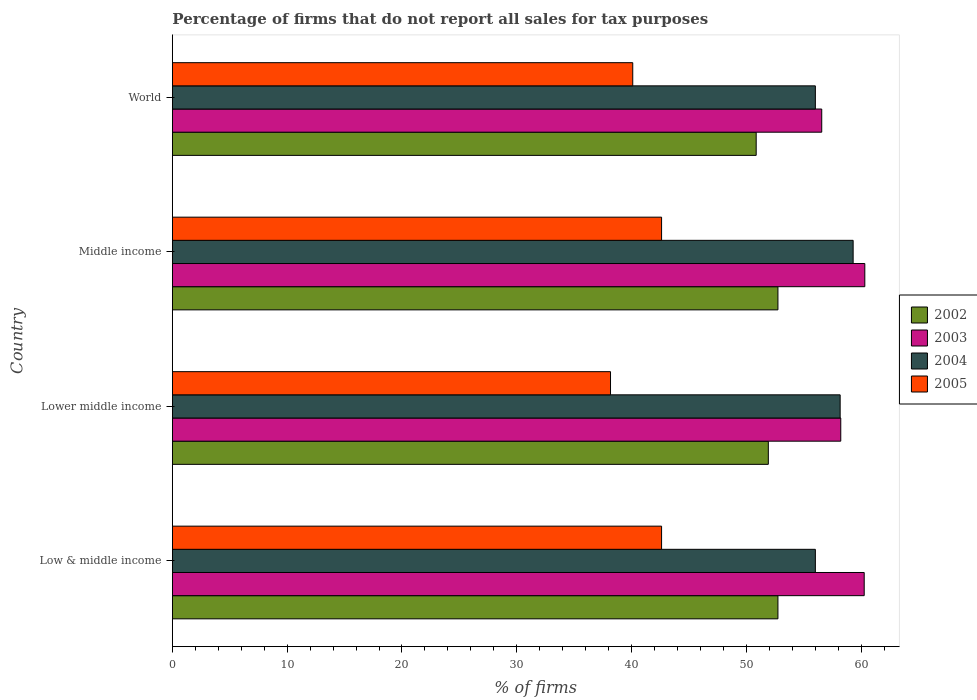How many different coloured bars are there?
Keep it short and to the point. 4. How many groups of bars are there?
Make the answer very short. 4. Are the number of bars on each tick of the Y-axis equal?
Provide a succinct answer. Yes. How many bars are there on the 1st tick from the bottom?
Ensure brevity in your answer.  4. What is the label of the 4th group of bars from the top?
Keep it short and to the point. Low & middle income. In how many cases, is the number of bars for a given country not equal to the number of legend labels?
Keep it short and to the point. 0. What is the percentage of firms that do not report all sales for tax purposes in 2004 in Lower middle income?
Your answer should be very brief. 58.16. Across all countries, what is the maximum percentage of firms that do not report all sales for tax purposes in 2003?
Give a very brief answer. 60.31. Across all countries, what is the minimum percentage of firms that do not report all sales for tax purposes in 2005?
Provide a succinct answer. 38.16. In which country was the percentage of firms that do not report all sales for tax purposes in 2002 maximum?
Make the answer very short. Low & middle income. In which country was the percentage of firms that do not report all sales for tax purposes in 2002 minimum?
Give a very brief answer. World. What is the total percentage of firms that do not report all sales for tax purposes in 2004 in the graph?
Provide a succinct answer. 229.47. What is the difference between the percentage of firms that do not report all sales for tax purposes in 2005 in Low & middle income and that in World?
Give a very brief answer. 2.51. What is the difference between the percentage of firms that do not report all sales for tax purposes in 2003 in Middle income and the percentage of firms that do not report all sales for tax purposes in 2005 in World?
Provide a short and direct response. 20.21. What is the average percentage of firms that do not report all sales for tax purposes in 2002 per country?
Your answer should be compact. 52.06. What is the difference between the percentage of firms that do not report all sales for tax purposes in 2004 and percentage of firms that do not report all sales for tax purposes in 2005 in World?
Your answer should be compact. 15.91. In how many countries, is the percentage of firms that do not report all sales for tax purposes in 2003 greater than 26 %?
Provide a short and direct response. 4. What is the ratio of the percentage of firms that do not report all sales for tax purposes in 2004 in Low & middle income to that in Lower middle income?
Offer a very short reply. 0.96. What is the difference between the highest and the second highest percentage of firms that do not report all sales for tax purposes in 2004?
Your answer should be compact. 1.13. What is the difference between the highest and the lowest percentage of firms that do not report all sales for tax purposes in 2003?
Offer a very short reply. 3.75. Is it the case that in every country, the sum of the percentage of firms that do not report all sales for tax purposes in 2004 and percentage of firms that do not report all sales for tax purposes in 2005 is greater than the sum of percentage of firms that do not report all sales for tax purposes in 2002 and percentage of firms that do not report all sales for tax purposes in 2003?
Ensure brevity in your answer.  Yes. What does the 2nd bar from the top in Low & middle income represents?
Your answer should be very brief. 2004. Is it the case that in every country, the sum of the percentage of firms that do not report all sales for tax purposes in 2003 and percentage of firms that do not report all sales for tax purposes in 2002 is greater than the percentage of firms that do not report all sales for tax purposes in 2005?
Your answer should be compact. Yes. Are all the bars in the graph horizontal?
Offer a terse response. Yes. Are the values on the major ticks of X-axis written in scientific E-notation?
Provide a short and direct response. No. Does the graph contain grids?
Your answer should be very brief. No. How many legend labels are there?
Keep it short and to the point. 4. How are the legend labels stacked?
Make the answer very short. Vertical. What is the title of the graph?
Provide a short and direct response. Percentage of firms that do not report all sales for tax purposes. What is the label or title of the X-axis?
Offer a very short reply. % of firms. What is the % of firms in 2002 in Low & middle income?
Your response must be concise. 52.75. What is the % of firms of 2003 in Low & middle income?
Your response must be concise. 60.26. What is the % of firms in 2004 in Low & middle income?
Make the answer very short. 56.01. What is the % of firms of 2005 in Low & middle income?
Offer a terse response. 42.61. What is the % of firms of 2002 in Lower middle income?
Your answer should be compact. 51.91. What is the % of firms of 2003 in Lower middle income?
Keep it short and to the point. 58.22. What is the % of firms in 2004 in Lower middle income?
Offer a terse response. 58.16. What is the % of firms of 2005 in Lower middle income?
Offer a very short reply. 38.16. What is the % of firms in 2002 in Middle income?
Your response must be concise. 52.75. What is the % of firms of 2003 in Middle income?
Your response must be concise. 60.31. What is the % of firms of 2004 in Middle income?
Offer a terse response. 59.3. What is the % of firms of 2005 in Middle income?
Provide a succinct answer. 42.61. What is the % of firms in 2002 in World?
Give a very brief answer. 50.85. What is the % of firms of 2003 in World?
Your answer should be very brief. 56.56. What is the % of firms of 2004 in World?
Give a very brief answer. 56.01. What is the % of firms in 2005 in World?
Provide a succinct answer. 40.1. Across all countries, what is the maximum % of firms in 2002?
Keep it short and to the point. 52.75. Across all countries, what is the maximum % of firms in 2003?
Keep it short and to the point. 60.31. Across all countries, what is the maximum % of firms of 2004?
Offer a very short reply. 59.3. Across all countries, what is the maximum % of firms of 2005?
Provide a succinct answer. 42.61. Across all countries, what is the minimum % of firms in 2002?
Give a very brief answer. 50.85. Across all countries, what is the minimum % of firms of 2003?
Your answer should be compact. 56.56. Across all countries, what is the minimum % of firms of 2004?
Keep it short and to the point. 56.01. Across all countries, what is the minimum % of firms of 2005?
Make the answer very short. 38.16. What is the total % of firms in 2002 in the graph?
Make the answer very short. 208.25. What is the total % of firms in 2003 in the graph?
Keep it short and to the point. 235.35. What is the total % of firms of 2004 in the graph?
Provide a succinct answer. 229.47. What is the total % of firms of 2005 in the graph?
Offer a terse response. 163.48. What is the difference between the % of firms in 2002 in Low & middle income and that in Lower middle income?
Offer a terse response. 0.84. What is the difference between the % of firms in 2003 in Low & middle income and that in Lower middle income?
Offer a terse response. 2.04. What is the difference between the % of firms in 2004 in Low & middle income and that in Lower middle income?
Keep it short and to the point. -2.16. What is the difference between the % of firms in 2005 in Low & middle income and that in Lower middle income?
Ensure brevity in your answer.  4.45. What is the difference between the % of firms in 2002 in Low & middle income and that in Middle income?
Provide a short and direct response. 0. What is the difference between the % of firms of 2003 in Low & middle income and that in Middle income?
Keep it short and to the point. -0.05. What is the difference between the % of firms in 2004 in Low & middle income and that in Middle income?
Your answer should be compact. -3.29. What is the difference between the % of firms of 2002 in Low & middle income and that in World?
Keep it short and to the point. 1.89. What is the difference between the % of firms in 2004 in Low & middle income and that in World?
Give a very brief answer. 0. What is the difference between the % of firms in 2005 in Low & middle income and that in World?
Give a very brief answer. 2.51. What is the difference between the % of firms of 2002 in Lower middle income and that in Middle income?
Provide a succinct answer. -0.84. What is the difference between the % of firms in 2003 in Lower middle income and that in Middle income?
Make the answer very short. -2.09. What is the difference between the % of firms of 2004 in Lower middle income and that in Middle income?
Ensure brevity in your answer.  -1.13. What is the difference between the % of firms of 2005 in Lower middle income and that in Middle income?
Make the answer very short. -4.45. What is the difference between the % of firms in 2002 in Lower middle income and that in World?
Provide a succinct answer. 1.06. What is the difference between the % of firms of 2003 in Lower middle income and that in World?
Give a very brief answer. 1.66. What is the difference between the % of firms in 2004 in Lower middle income and that in World?
Offer a very short reply. 2.16. What is the difference between the % of firms of 2005 in Lower middle income and that in World?
Make the answer very short. -1.94. What is the difference between the % of firms of 2002 in Middle income and that in World?
Ensure brevity in your answer.  1.89. What is the difference between the % of firms of 2003 in Middle income and that in World?
Keep it short and to the point. 3.75. What is the difference between the % of firms of 2004 in Middle income and that in World?
Your response must be concise. 3.29. What is the difference between the % of firms of 2005 in Middle income and that in World?
Give a very brief answer. 2.51. What is the difference between the % of firms in 2002 in Low & middle income and the % of firms in 2003 in Lower middle income?
Your response must be concise. -5.47. What is the difference between the % of firms of 2002 in Low & middle income and the % of firms of 2004 in Lower middle income?
Keep it short and to the point. -5.42. What is the difference between the % of firms of 2002 in Low & middle income and the % of firms of 2005 in Lower middle income?
Provide a succinct answer. 14.58. What is the difference between the % of firms in 2003 in Low & middle income and the % of firms in 2004 in Lower middle income?
Offer a terse response. 2.1. What is the difference between the % of firms of 2003 in Low & middle income and the % of firms of 2005 in Lower middle income?
Give a very brief answer. 22.1. What is the difference between the % of firms of 2004 in Low & middle income and the % of firms of 2005 in Lower middle income?
Offer a terse response. 17.84. What is the difference between the % of firms of 2002 in Low & middle income and the % of firms of 2003 in Middle income?
Offer a terse response. -7.57. What is the difference between the % of firms of 2002 in Low & middle income and the % of firms of 2004 in Middle income?
Ensure brevity in your answer.  -6.55. What is the difference between the % of firms of 2002 in Low & middle income and the % of firms of 2005 in Middle income?
Your response must be concise. 10.13. What is the difference between the % of firms in 2003 in Low & middle income and the % of firms in 2005 in Middle income?
Give a very brief answer. 17.65. What is the difference between the % of firms in 2004 in Low & middle income and the % of firms in 2005 in Middle income?
Provide a succinct answer. 13.39. What is the difference between the % of firms in 2002 in Low & middle income and the % of firms in 2003 in World?
Your answer should be compact. -3.81. What is the difference between the % of firms of 2002 in Low & middle income and the % of firms of 2004 in World?
Give a very brief answer. -3.26. What is the difference between the % of firms in 2002 in Low & middle income and the % of firms in 2005 in World?
Your answer should be very brief. 12.65. What is the difference between the % of firms in 2003 in Low & middle income and the % of firms in 2004 in World?
Keep it short and to the point. 4.25. What is the difference between the % of firms in 2003 in Low & middle income and the % of firms in 2005 in World?
Keep it short and to the point. 20.16. What is the difference between the % of firms of 2004 in Low & middle income and the % of firms of 2005 in World?
Your answer should be compact. 15.91. What is the difference between the % of firms in 2002 in Lower middle income and the % of firms in 2003 in Middle income?
Keep it short and to the point. -8.4. What is the difference between the % of firms of 2002 in Lower middle income and the % of firms of 2004 in Middle income?
Ensure brevity in your answer.  -7.39. What is the difference between the % of firms of 2002 in Lower middle income and the % of firms of 2005 in Middle income?
Make the answer very short. 9.3. What is the difference between the % of firms in 2003 in Lower middle income and the % of firms in 2004 in Middle income?
Provide a short and direct response. -1.08. What is the difference between the % of firms of 2003 in Lower middle income and the % of firms of 2005 in Middle income?
Provide a succinct answer. 15.61. What is the difference between the % of firms of 2004 in Lower middle income and the % of firms of 2005 in Middle income?
Your answer should be compact. 15.55. What is the difference between the % of firms of 2002 in Lower middle income and the % of firms of 2003 in World?
Keep it short and to the point. -4.65. What is the difference between the % of firms in 2002 in Lower middle income and the % of firms in 2004 in World?
Give a very brief answer. -4.1. What is the difference between the % of firms of 2002 in Lower middle income and the % of firms of 2005 in World?
Keep it short and to the point. 11.81. What is the difference between the % of firms in 2003 in Lower middle income and the % of firms in 2004 in World?
Make the answer very short. 2.21. What is the difference between the % of firms of 2003 in Lower middle income and the % of firms of 2005 in World?
Offer a very short reply. 18.12. What is the difference between the % of firms in 2004 in Lower middle income and the % of firms in 2005 in World?
Keep it short and to the point. 18.07. What is the difference between the % of firms of 2002 in Middle income and the % of firms of 2003 in World?
Your response must be concise. -3.81. What is the difference between the % of firms in 2002 in Middle income and the % of firms in 2004 in World?
Provide a short and direct response. -3.26. What is the difference between the % of firms of 2002 in Middle income and the % of firms of 2005 in World?
Give a very brief answer. 12.65. What is the difference between the % of firms of 2003 in Middle income and the % of firms of 2004 in World?
Provide a succinct answer. 4.31. What is the difference between the % of firms of 2003 in Middle income and the % of firms of 2005 in World?
Give a very brief answer. 20.21. What is the difference between the % of firms in 2004 in Middle income and the % of firms in 2005 in World?
Your answer should be compact. 19.2. What is the average % of firms of 2002 per country?
Give a very brief answer. 52.06. What is the average % of firms of 2003 per country?
Give a very brief answer. 58.84. What is the average % of firms in 2004 per country?
Provide a short and direct response. 57.37. What is the average % of firms in 2005 per country?
Keep it short and to the point. 40.87. What is the difference between the % of firms of 2002 and % of firms of 2003 in Low & middle income?
Make the answer very short. -7.51. What is the difference between the % of firms of 2002 and % of firms of 2004 in Low & middle income?
Your answer should be very brief. -3.26. What is the difference between the % of firms in 2002 and % of firms in 2005 in Low & middle income?
Ensure brevity in your answer.  10.13. What is the difference between the % of firms in 2003 and % of firms in 2004 in Low & middle income?
Your response must be concise. 4.25. What is the difference between the % of firms in 2003 and % of firms in 2005 in Low & middle income?
Your answer should be compact. 17.65. What is the difference between the % of firms in 2004 and % of firms in 2005 in Low & middle income?
Offer a terse response. 13.39. What is the difference between the % of firms in 2002 and % of firms in 2003 in Lower middle income?
Your response must be concise. -6.31. What is the difference between the % of firms of 2002 and % of firms of 2004 in Lower middle income?
Your answer should be compact. -6.26. What is the difference between the % of firms of 2002 and % of firms of 2005 in Lower middle income?
Provide a short and direct response. 13.75. What is the difference between the % of firms in 2003 and % of firms in 2004 in Lower middle income?
Offer a very short reply. 0.05. What is the difference between the % of firms in 2003 and % of firms in 2005 in Lower middle income?
Offer a terse response. 20.06. What is the difference between the % of firms in 2004 and % of firms in 2005 in Lower middle income?
Provide a succinct answer. 20. What is the difference between the % of firms in 2002 and % of firms in 2003 in Middle income?
Give a very brief answer. -7.57. What is the difference between the % of firms in 2002 and % of firms in 2004 in Middle income?
Your response must be concise. -6.55. What is the difference between the % of firms of 2002 and % of firms of 2005 in Middle income?
Your answer should be very brief. 10.13. What is the difference between the % of firms of 2003 and % of firms of 2004 in Middle income?
Ensure brevity in your answer.  1.02. What is the difference between the % of firms in 2003 and % of firms in 2005 in Middle income?
Your answer should be compact. 17.7. What is the difference between the % of firms in 2004 and % of firms in 2005 in Middle income?
Give a very brief answer. 16.69. What is the difference between the % of firms in 2002 and % of firms in 2003 in World?
Keep it short and to the point. -5.71. What is the difference between the % of firms in 2002 and % of firms in 2004 in World?
Ensure brevity in your answer.  -5.15. What is the difference between the % of firms of 2002 and % of firms of 2005 in World?
Your answer should be very brief. 10.75. What is the difference between the % of firms in 2003 and % of firms in 2004 in World?
Offer a very short reply. 0.56. What is the difference between the % of firms in 2003 and % of firms in 2005 in World?
Your answer should be compact. 16.46. What is the difference between the % of firms of 2004 and % of firms of 2005 in World?
Provide a succinct answer. 15.91. What is the ratio of the % of firms in 2002 in Low & middle income to that in Lower middle income?
Ensure brevity in your answer.  1.02. What is the ratio of the % of firms in 2003 in Low & middle income to that in Lower middle income?
Keep it short and to the point. 1.04. What is the ratio of the % of firms in 2004 in Low & middle income to that in Lower middle income?
Keep it short and to the point. 0.96. What is the ratio of the % of firms of 2005 in Low & middle income to that in Lower middle income?
Offer a terse response. 1.12. What is the ratio of the % of firms of 2002 in Low & middle income to that in Middle income?
Ensure brevity in your answer.  1. What is the ratio of the % of firms of 2004 in Low & middle income to that in Middle income?
Offer a terse response. 0.94. What is the ratio of the % of firms of 2002 in Low & middle income to that in World?
Your answer should be very brief. 1.04. What is the ratio of the % of firms of 2003 in Low & middle income to that in World?
Your answer should be very brief. 1.07. What is the ratio of the % of firms of 2004 in Low & middle income to that in World?
Offer a very short reply. 1. What is the ratio of the % of firms in 2005 in Low & middle income to that in World?
Your answer should be very brief. 1.06. What is the ratio of the % of firms in 2002 in Lower middle income to that in Middle income?
Keep it short and to the point. 0.98. What is the ratio of the % of firms of 2003 in Lower middle income to that in Middle income?
Your answer should be very brief. 0.97. What is the ratio of the % of firms in 2004 in Lower middle income to that in Middle income?
Keep it short and to the point. 0.98. What is the ratio of the % of firms of 2005 in Lower middle income to that in Middle income?
Your answer should be very brief. 0.9. What is the ratio of the % of firms of 2002 in Lower middle income to that in World?
Your answer should be compact. 1.02. What is the ratio of the % of firms of 2003 in Lower middle income to that in World?
Provide a short and direct response. 1.03. What is the ratio of the % of firms of 2004 in Lower middle income to that in World?
Offer a very short reply. 1.04. What is the ratio of the % of firms in 2005 in Lower middle income to that in World?
Your response must be concise. 0.95. What is the ratio of the % of firms of 2002 in Middle income to that in World?
Ensure brevity in your answer.  1.04. What is the ratio of the % of firms in 2003 in Middle income to that in World?
Offer a very short reply. 1.07. What is the ratio of the % of firms in 2004 in Middle income to that in World?
Your answer should be very brief. 1.06. What is the ratio of the % of firms of 2005 in Middle income to that in World?
Provide a short and direct response. 1.06. What is the difference between the highest and the second highest % of firms of 2002?
Offer a very short reply. 0. What is the difference between the highest and the second highest % of firms of 2003?
Offer a terse response. 0.05. What is the difference between the highest and the second highest % of firms of 2004?
Your answer should be compact. 1.13. What is the difference between the highest and the second highest % of firms in 2005?
Your answer should be compact. 0. What is the difference between the highest and the lowest % of firms of 2002?
Your answer should be compact. 1.89. What is the difference between the highest and the lowest % of firms of 2003?
Your response must be concise. 3.75. What is the difference between the highest and the lowest % of firms in 2004?
Your response must be concise. 3.29. What is the difference between the highest and the lowest % of firms in 2005?
Keep it short and to the point. 4.45. 